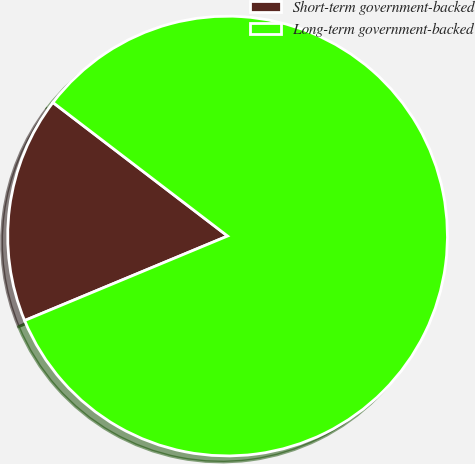Convert chart. <chart><loc_0><loc_0><loc_500><loc_500><pie_chart><fcel>Short-term government-backed<fcel>Long-term government-backed<nl><fcel>16.67%<fcel>83.33%<nl></chart> 